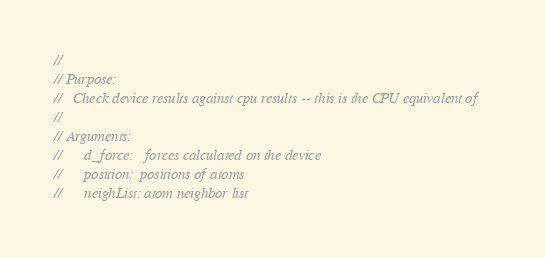<code> <loc_0><loc_0><loc_500><loc_500><_Cuda_>//
// Purpose:
//   Check device results against cpu results -- this is the CPU equivalent of
//
// Arguments:
//      d_force:   forces calculated on the device
//      position:  positions of atoms
//      neighList: atom neighbor list</code> 